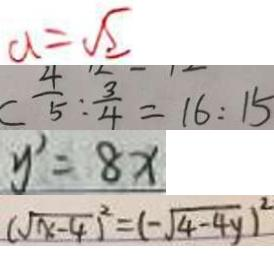<formula> <loc_0><loc_0><loc_500><loc_500>a = \sqrt { 2 } 
 C \frac { 4 } { 5 } : \frac { 3 } { 4 } = 1 6 : 1 5 
 y ^ { \prime } = 8 x 
 ( \sqrt { x - 4 } ) ^ { 2 } = ( - \sqrt { 4 - 4 y } ) ^ { 2 }</formula> 